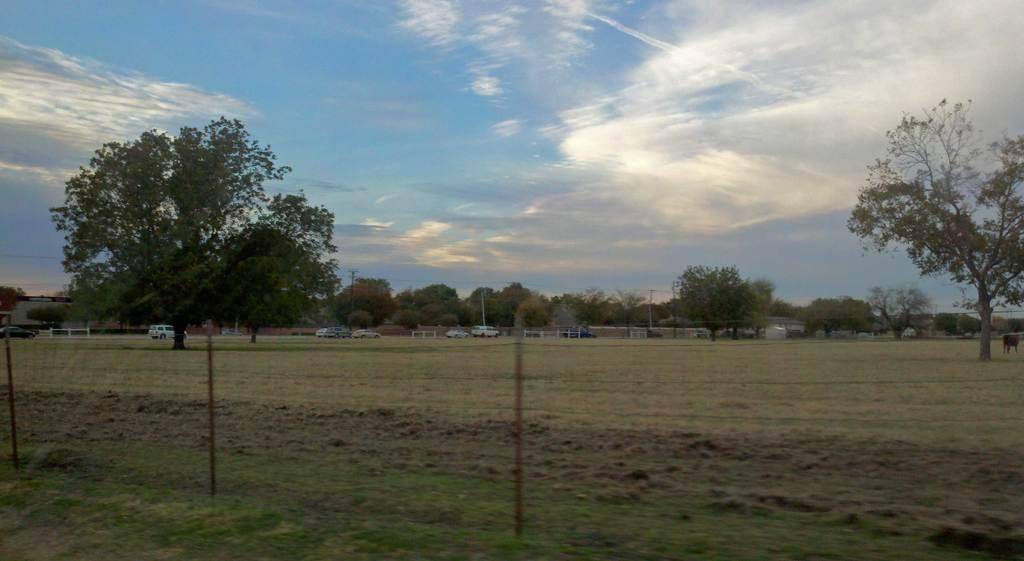What is located in the foreground of the image? There is a net in the foreground of the image. What can be seen in the background of the image? There are trees, cars, and the sky visible in the background of the image. What type of vegetation is present in the image? There are trees and grass in the image. What is the condition of the sky in the image? The sky is visible in the background of the image, and there are clouds present. What type of religious request can be seen being made in the image? There is no religious request present in the image; it features a net, trees, cars, sky, clouds, and grass. Can you tell me how many animals are visible in the zoo in the image? There is no zoo present in the image; it features a net, trees, cars, sky, clouds, and grass. 